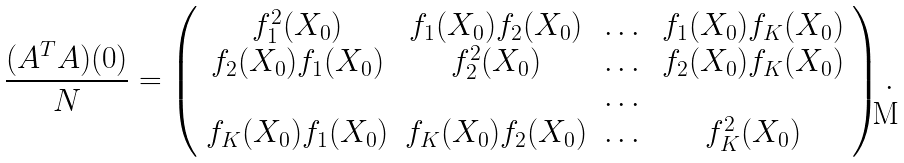Convert formula to latex. <formula><loc_0><loc_0><loc_500><loc_500>\frac { ( A ^ { T } A ) ( 0 ) } { N } = \left ( \begin{array} { c c c c } f ^ { 2 } _ { 1 } ( X _ { 0 } ) & f _ { 1 } ( X _ { 0 } ) f _ { 2 } ( X _ { 0 } ) & \dots & f _ { 1 } ( X _ { 0 } ) f _ { K } ( X _ { 0 } ) \\ f _ { 2 } ( X _ { 0 } ) f _ { 1 } ( X _ { 0 } ) & f ^ { 2 } _ { 2 } ( X _ { 0 } ) & \dots & f _ { 2 } ( X _ { 0 } ) f _ { K } ( X _ { 0 } ) \\ & & \dots & \\ f _ { K } ( X _ { 0 } ) f _ { 1 } ( X _ { 0 } ) & f _ { K } ( X _ { 0 } ) f _ { 2 } ( X _ { 0 } ) & \dots & f ^ { 2 } _ { K } ( X _ { 0 } ) \\ \end{array} \right ) .</formula> 